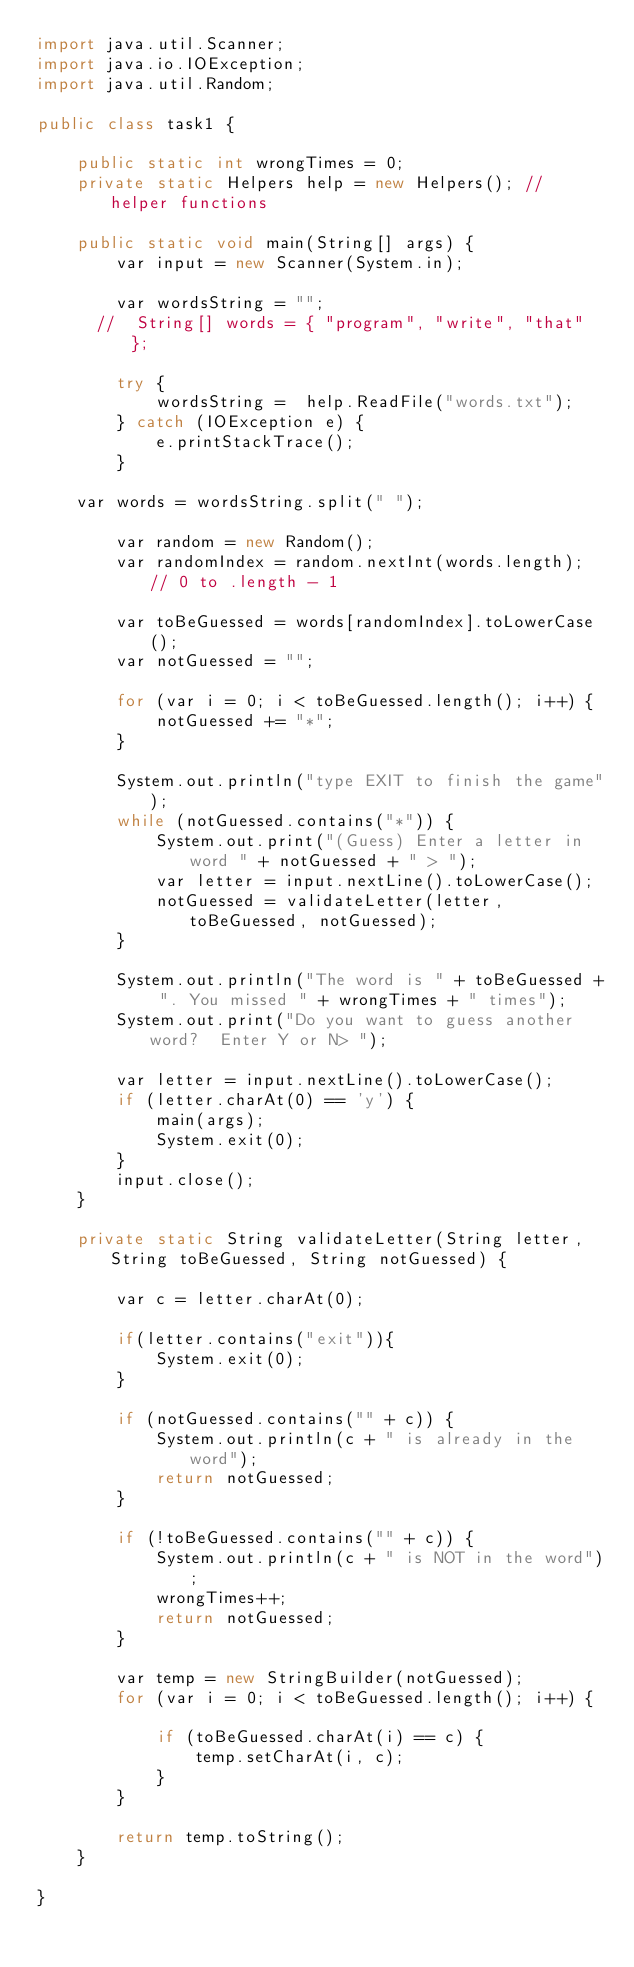Convert code to text. <code><loc_0><loc_0><loc_500><loc_500><_Java_>import java.util.Scanner;
import java.io.IOException;
import java.util.Random;

public class task1 {

    public static int wrongTimes = 0;
    private static Helpers help = new Helpers(); // helper functions

    public static void main(String[] args) {
        var input = new Scanner(System.in);

        var wordsString = "";
      //  String[] words = { "program", "write", "that" };

        try {
            wordsString =  help.ReadFile("words.txt");
        } catch (IOException e) {
            e.printStackTrace();
        }

    var words = wordsString.split(" ");

        var random = new Random();
        var randomIndex = random.nextInt(words.length); // 0 to .length - 1

        var toBeGuessed = words[randomIndex].toLowerCase();
        var notGuessed = "";

        for (var i = 0; i < toBeGuessed.length(); i++) {
            notGuessed += "*";
        }
        
        System.out.println("type EXIT to finish the game");
        while (notGuessed.contains("*")) {
            System.out.print("(Guess) Enter a letter in word " + notGuessed + " > ");
            var letter = input.nextLine().toLowerCase();
            notGuessed = validateLetter(letter, toBeGuessed, notGuessed);
        }

        System.out.println("The word is " + toBeGuessed + ". You missed " + wrongTimes + " times");
        System.out.print("Do you want to guess another word?  Enter Y or N> ");

        var letter = input.nextLine().toLowerCase();
        if (letter.charAt(0) == 'y') {
            main(args);
            System.exit(0);
        }
        input.close();
    }

    private static String validateLetter(String letter, String toBeGuessed, String notGuessed) {

        var c = letter.charAt(0);

        if(letter.contains("exit")){
            System.exit(0);
        }

        if (notGuessed.contains("" + c)) {
            System.out.println(c + " is already in the word");
            return notGuessed;
        }

        if (!toBeGuessed.contains("" + c)) {
            System.out.println(c + " is NOT in the word");
            wrongTimes++;
            return notGuessed;
        }

        var temp = new StringBuilder(notGuessed);
        for (var i = 0; i < toBeGuessed.length(); i++) {

            if (toBeGuessed.charAt(i) == c) {
                temp.setCharAt(i, c);
            }
        }

        return temp.toString();
    }

}</code> 